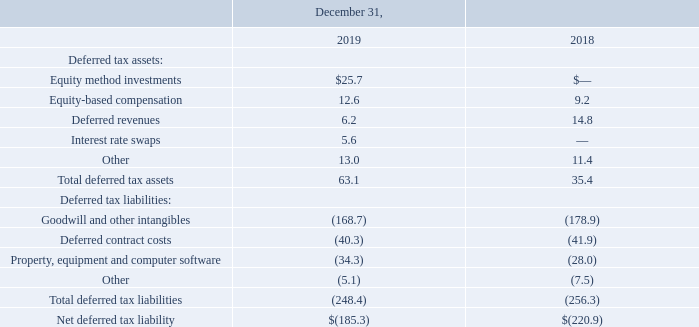(19) Income Taxes
As of December 31, 2019 and 2018, the components of deferred tax assets primarily relate to equity method investments, equity-based compensation, deferred revenues, interest rate swaps, employee benefits accruals and deferred compensation. As of December 31, 2019 and 2018, the components of deferred tax liabilities primarily relate to depreciation and amortization of intangible assets, property and equipment and deferred contract costs.
The significant components of deferred tax assets and liabilities consist of the following (in millions):
What did the components of deferred tax assets primarily related to? Equity method investments, equity-based compensation, deferred revenues, interest rate swaps, employee benefits accruals and deferred compensation. What was the amount of Equity method investments in 2019?
Answer scale should be: million. 25.7. Which years does the table provide information for  components of deferred tax assets and liabilities? 2019, 2018. What was the change in equity-based compensation between 2018 and 2019?
Answer scale should be: million. 12.6-9.2
Answer: 3.4. How many years did deferred revenues exceed $10 million? 2018
Answer: 1. What was the percentage change in Total deferred tax liabilities between 2018 and 2019?
Answer scale should be: percent. (-248.4-(-256.3))/-256.3
Answer: -3.08. 